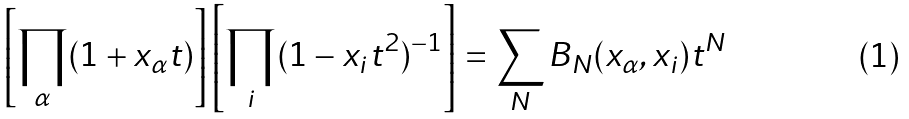<formula> <loc_0><loc_0><loc_500><loc_500>\left [ \prod _ { \alpha } ( 1 + x _ { \alpha } t ) \right ] \left [ \prod _ { i } ( 1 - x _ { i } t ^ { 2 } ) ^ { - 1 } \right ] = \sum _ { N } B _ { N } ( x _ { \alpha } , x _ { i } ) t ^ { N }</formula> 